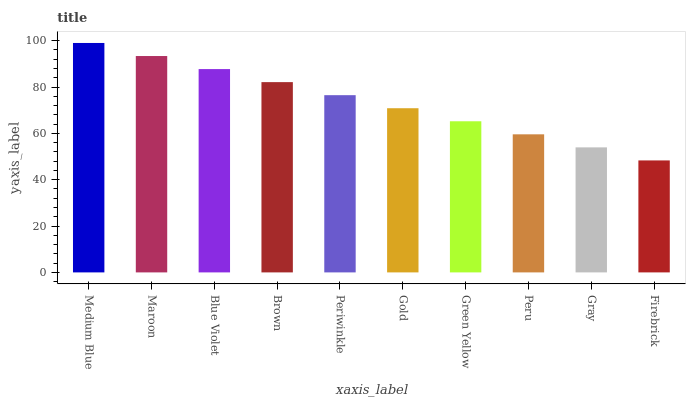Is Maroon the minimum?
Answer yes or no. No. Is Maroon the maximum?
Answer yes or no. No. Is Medium Blue greater than Maroon?
Answer yes or no. Yes. Is Maroon less than Medium Blue?
Answer yes or no. Yes. Is Maroon greater than Medium Blue?
Answer yes or no. No. Is Medium Blue less than Maroon?
Answer yes or no. No. Is Periwinkle the high median?
Answer yes or no. Yes. Is Gold the low median?
Answer yes or no. Yes. Is Medium Blue the high median?
Answer yes or no. No. Is Peru the low median?
Answer yes or no. No. 